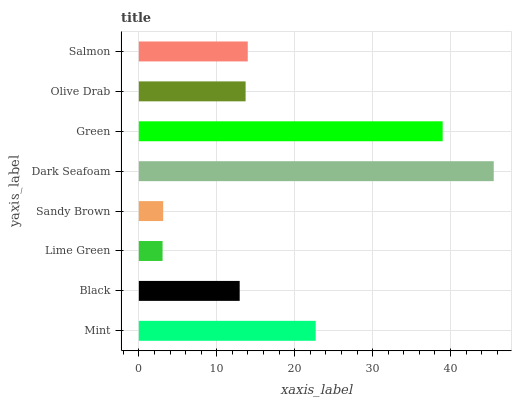Is Lime Green the minimum?
Answer yes or no. Yes. Is Dark Seafoam the maximum?
Answer yes or no. Yes. Is Black the minimum?
Answer yes or no. No. Is Black the maximum?
Answer yes or no. No. Is Mint greater than Black?
Answer yes or no. Yes. Is Black less than Mint?
Answer yes or no. Yes. Is Black greater than Mint?
Answer yes or no. No. Is Mint less than Black?
Answer yes or no. No. Is Salmon the high median?
Answer yes or no. Yes. Is Olive Drab the low median?
Answer yes or no. Yes. Is Mint the high median?
Answer yes or no. No. Is Black the low median?
Answer yes or no. No. 